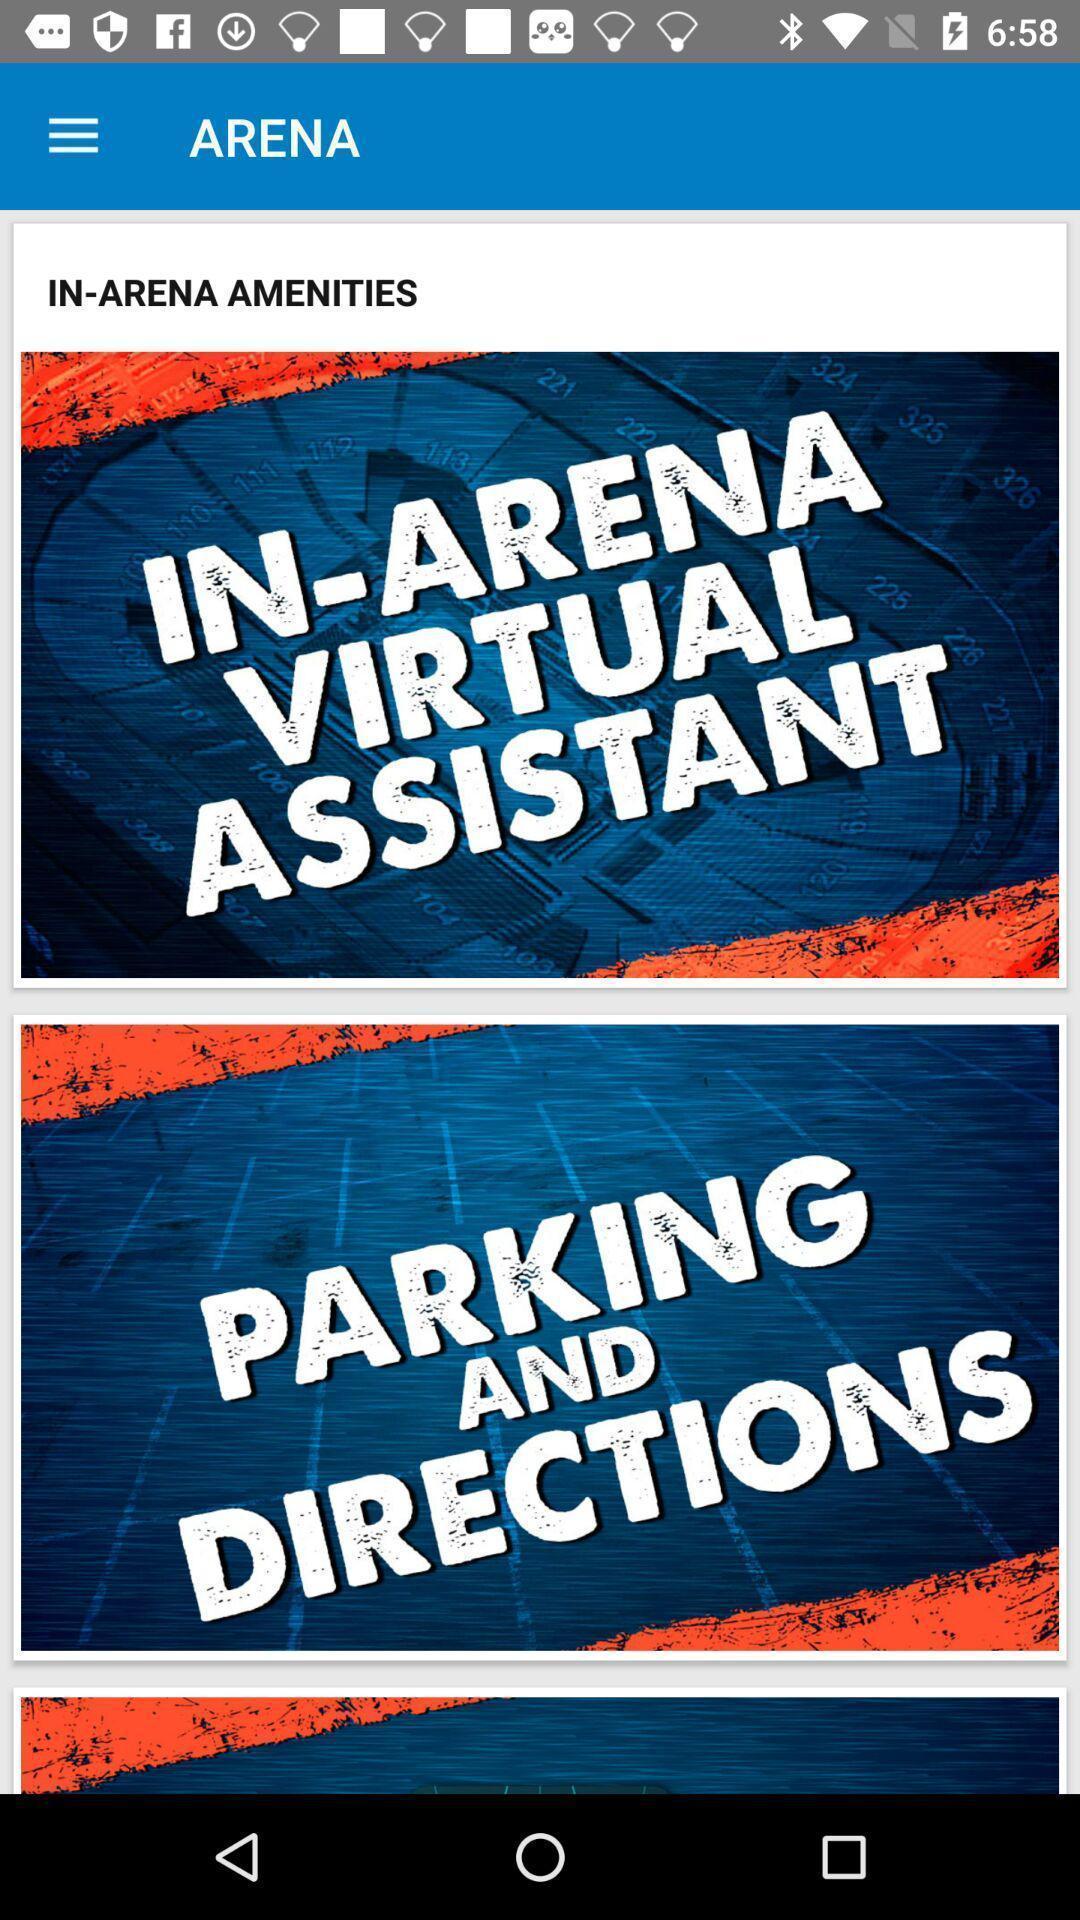Tell me about the visual elements in this screen capture. Page of in arena amenties. 